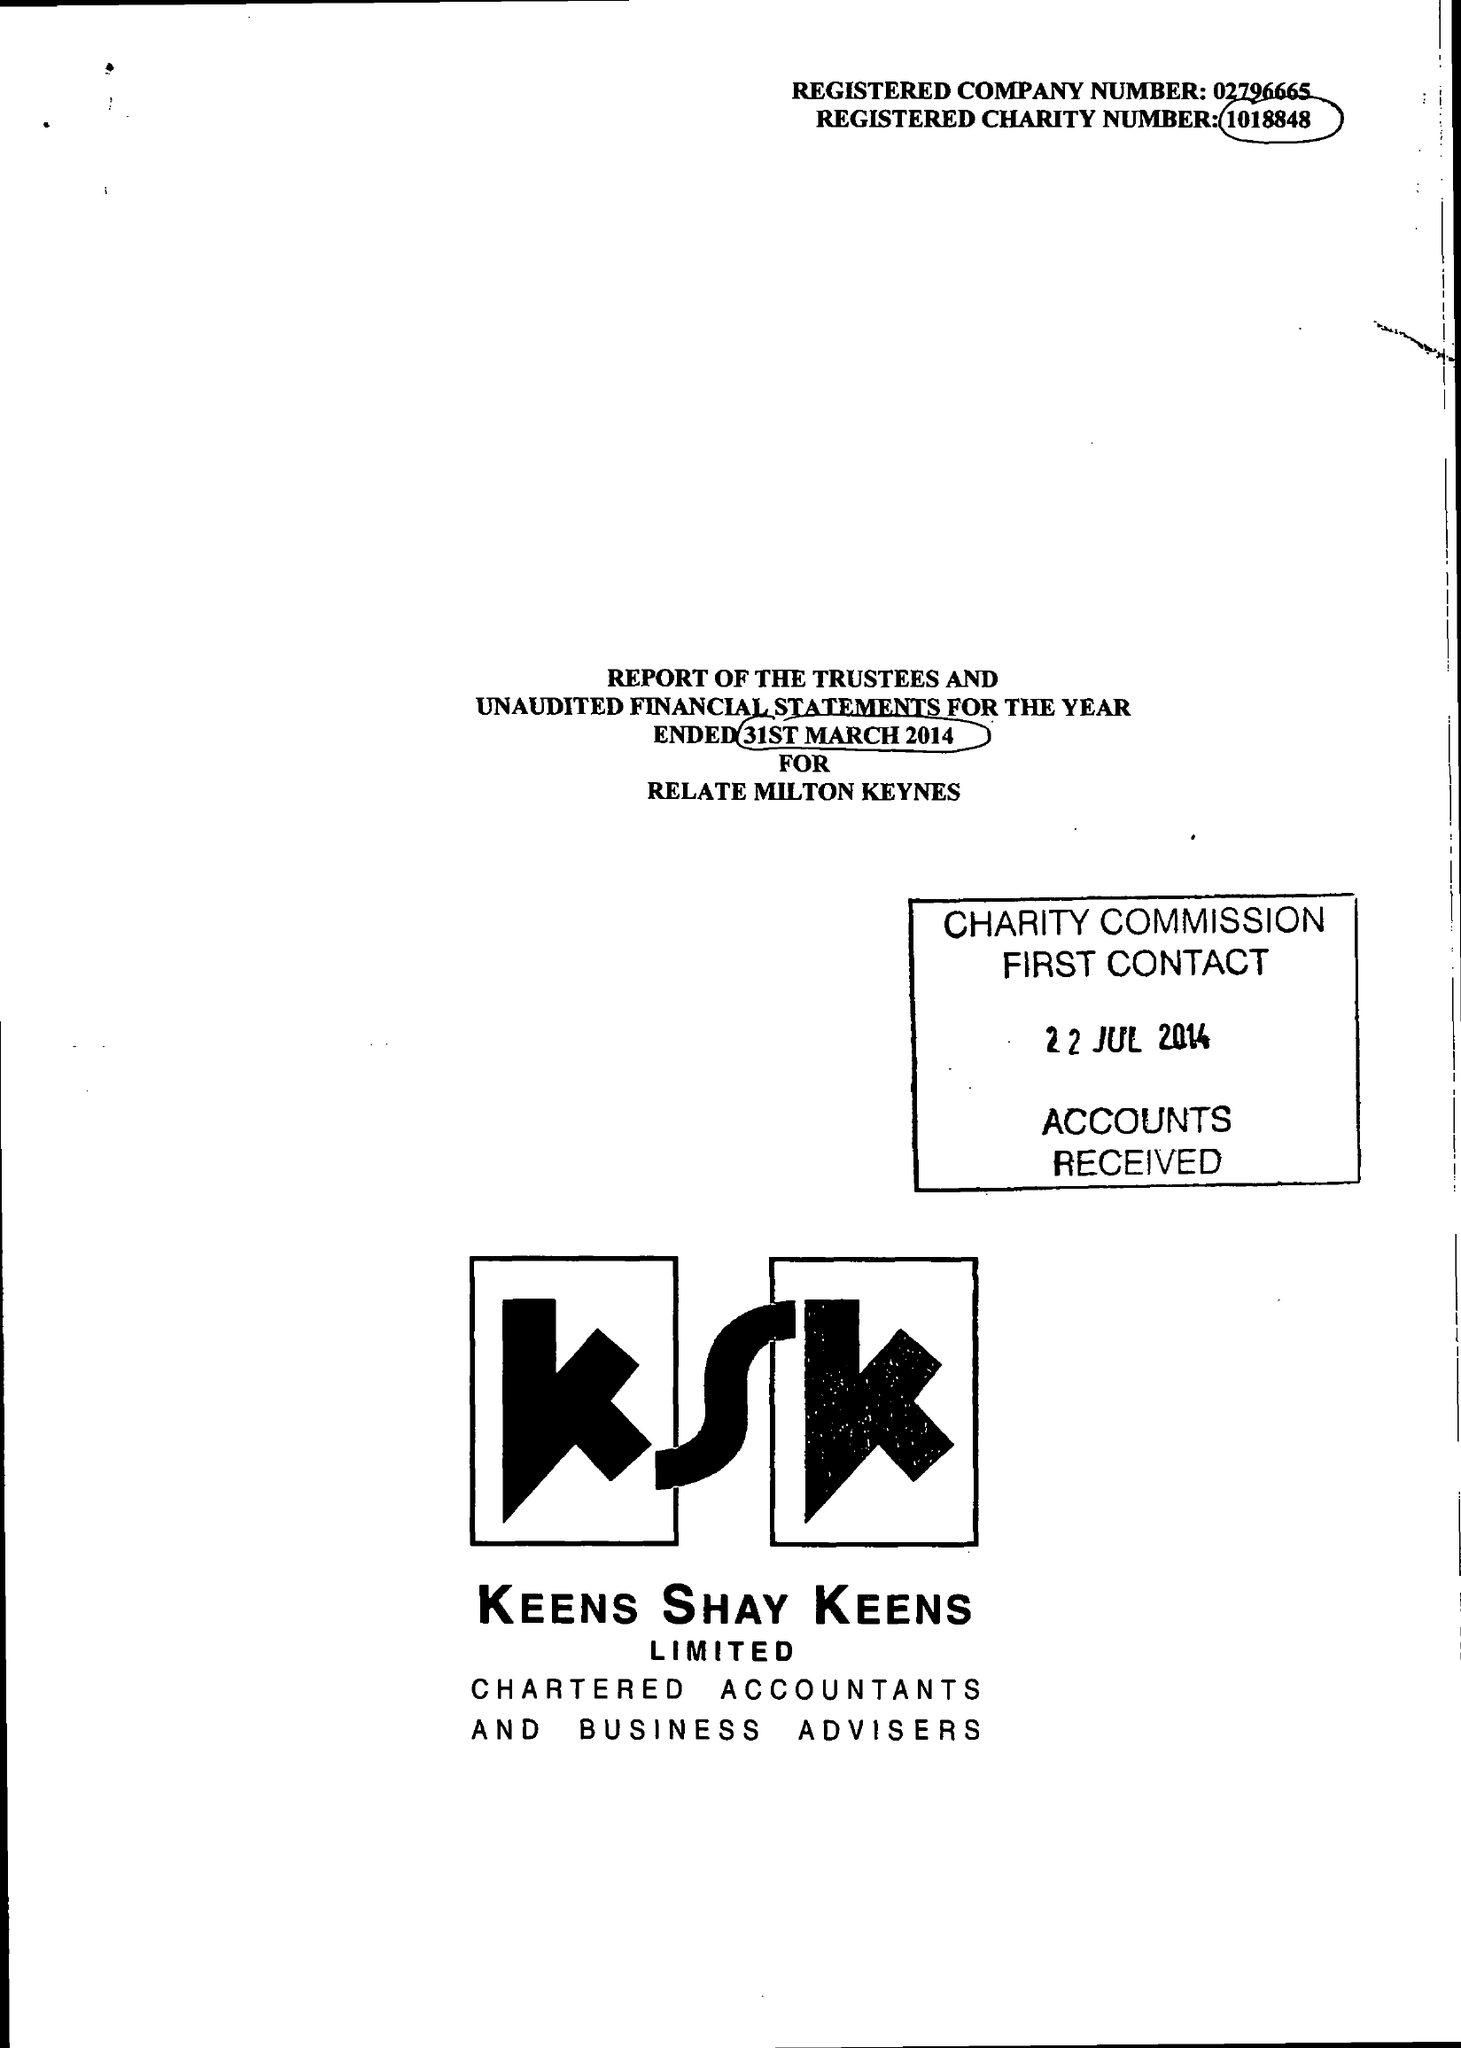What is the value for the report_date?
Answer the question using a single word or phrase. 2014-03-31 